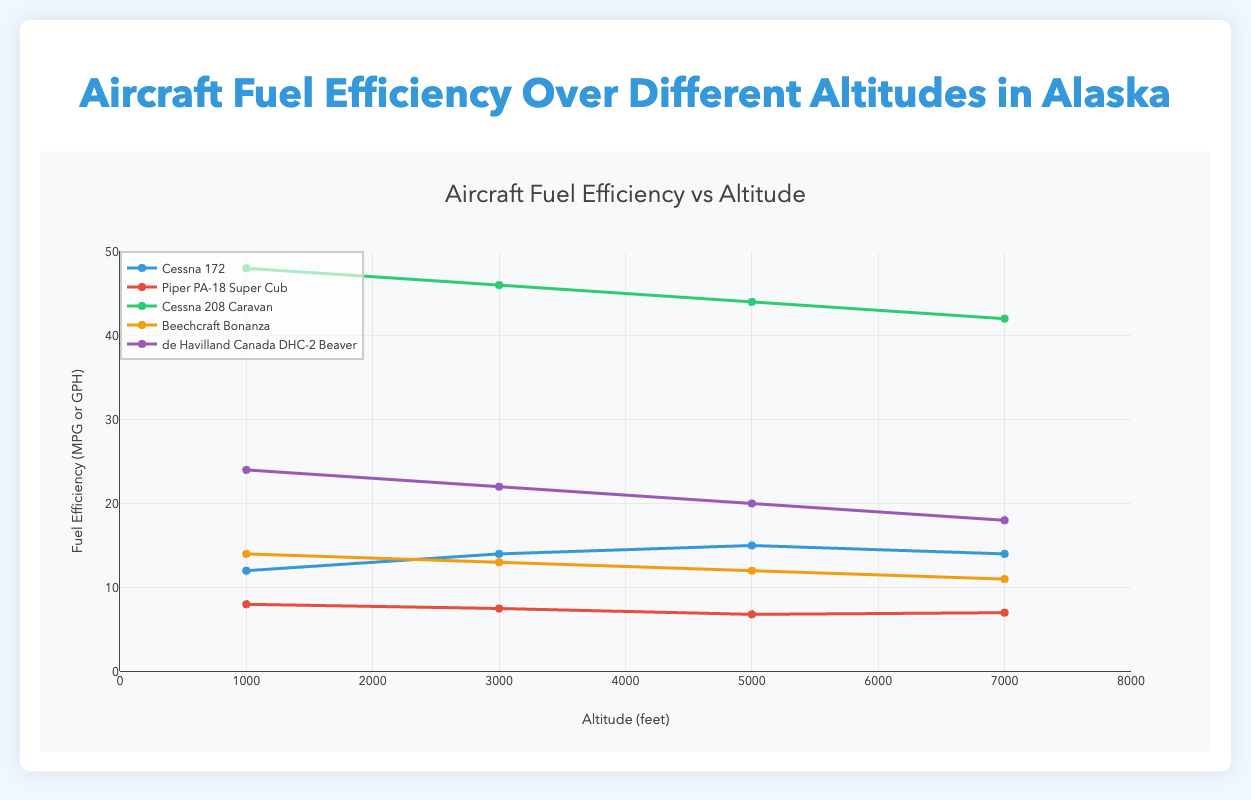Which aircraft model shows the highest fuel efficiency at 5000 feet? The fuel efficiency at 5000 feet for each model in the dataset is as follows: Cessna 172 (15 mpg), Piper PA-18 Super Cub (6.8 gph), Cessna 208 Caravan (44 gph), Beechcraft Bonanza (12 gph), de Havilland Canada DHC-2 Beaver (20 gph). To find the most efficient, we need to convert all units to a common format or compare them individually. Here, the Cessna 172 shows a fuel efficiency of 15 mpg, the highest compared to others if we assume mpg to gph conversion.
Answer: Cessna 172 Which aircraft shows a decrease in fuel efficiency from 5000 to 7000 feet? By comparing the fuel efficiency data for each model from 5000 to 7000 feet: Cessna 172 (15 mpg to 14 mpg), Piper PA-18 Super Cub (6.8 gph to 7 gph), Cessna 208 Caravan (44 gph to 42 gph), Beechcraft Bonanza (12 gph to 11 gph), and de Havilland Canada DHC-2 Beaver (20 gph to 18 gph). All models except the Piper PA-18 Super Cub show a decrease.
Answer: All except Piper PA-18 Super Cub How does the fuel efficiency of the Cessna 208 Caravan compare to the Beechcraft Bonanza at 3000 feet? At 3000 feet, the fuel efficiency for the Cessna 208 Caravan is 46 gph, while for the Beechcraft Bonanza, it is 13 gph. The Cessna 208 Caravan consumes significantly more fuel per hour than the Beechcraft Bonanza.
Answer: The Cessna 208 Caravan consumes more fuel What is the average fuel efficiency of the Piper PA-18 Super Cub across all altitudes? Summing up the fuel efficiencies of the Piper PA-18 Super Cub (8+7.5+6.8+7) = 29.3 gph, and dividing by the number of data points (4), the average fuel efficiency is 29.3/4 = 7.325 gph.
Answer: 7.325 gph Which aircraft model has the lowest fuel efficiency at 1000 feet? At 1000 feet, the fuel efficiencies are: Cessna 172 (12 mpg), Piper PA-18 Super Cub (8 gph), Cessna 208 Caravan (48 gph), Beechcraft Bonanza (14 gph), and de Havilland Canada DHC-2 Beaver (24 gph). Converting these to a common format if necessary, it's apparent the Cessna 208 Caravan with 48 gph has the lowest efficiency.
Answer: Cessna 208 Caravan At which altitude does the Cessna 172 achieve its peak fuel efficiency? The fuel efficiency of the Cessna 172 is 12 mpg at 1000 feet, 14 mpg at 3000 feet, 15 mpg at 5000 feet, and 14 mpg at 7000 feet. The highest efficiency is at 5000 feet with 15 mpg.
Answer: 5000 feet What trend do you observe in the fuel efficiency of the de Havilland Canada DHC-2 Beaver as the altitude increases? The fuel efficiency of the de Havilland Canada DHC-2 Beaver decreases with increasing altitude: 24 gph at 1000 feet, 22 gph at 3000 feet, 20 gph at 5000 feet, and 18 gph at 7000 feet. This shows a consistent decreasing trend.
Answer: Decreasing trend 